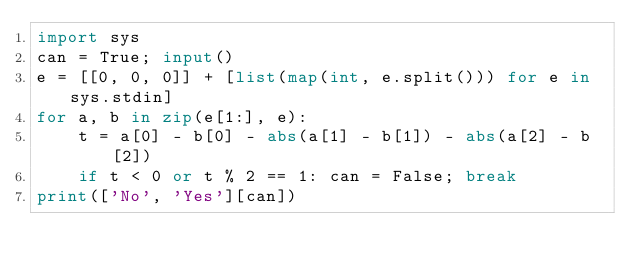<code> <loc_0><loc_0><loc_500><loc_500><_Python_>import sys
can = True; input()
e = [[0, 0, 0]] + [list(map(int, e.split())) for e in sys.stdin]
for a, b in zip(e[1:], e):
    t = a[0] - b[0] - abs(a[1] - b[1]) - abs(a[2] - b[2])
    if t < 0 or t % 2 == 1: can = False; break
print(['No', 'Yes'][can])</code> 